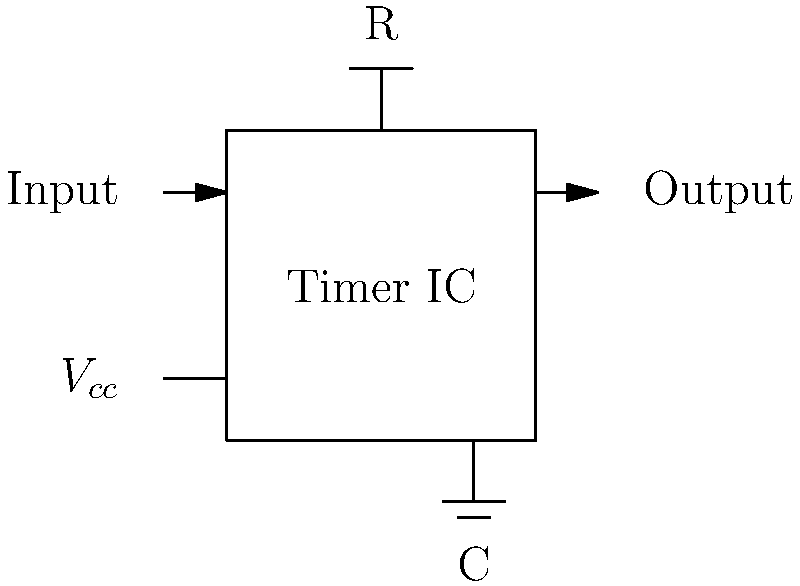As a retail worker, you've been asked to help set up a timer circuit for the automated Christmas lighting in your store. The circuit uses a 555 timer IC in astable mode. If the desired on-time for the lights is 8 hours and the off-time is 16 hours (matching your store's operating hours), what should be the ratio of resistor values $R_1$ and $R_2$ in the circuit? Let's approach this step-by-step:

1) In astable mode, the 555 timer's on-time ($t_{on}$) and off-time ($t_{off}$) are given by:

   $t_{on} = 0.693(R_1 + R_2)C$
   $t_{off} = 0.693(R_2)C$

2) We're given that $t_{on} = 8$ hours and $t_{off} = 16$ hours.

3) Dividing these equations:

   $\frac{t_{on}}{t_{off}} = \frac{0.693(R_1 + R_2)C}{0.693(R_2)C} = \frac{R_1 + R_2}{R_2}$

4) Substituting the given times:

   $\frac{8}{16} = \frac{R_1 + R_2}{R_2}$

5) Simplifying:

   $\frac{1}{2} = \frac{R_1 + R_2}{R_2}$

6) Cross-multiplying:

   $R_2 = 2(R_1 + R_2)$
   $R_2 = 2R_1 + 2R_2$

7) Subtracting $2R_2$ from both sides:

   $-R_2 = 2R_1$
   $R_2 = -2R_1$

8) Taking the absolute value (as resistance is always positive):

   $R_2 = 2R_1$

Therefore, the ratio of $R_1$ to $R_2$ should be 1:2.
Answer: 1:2 